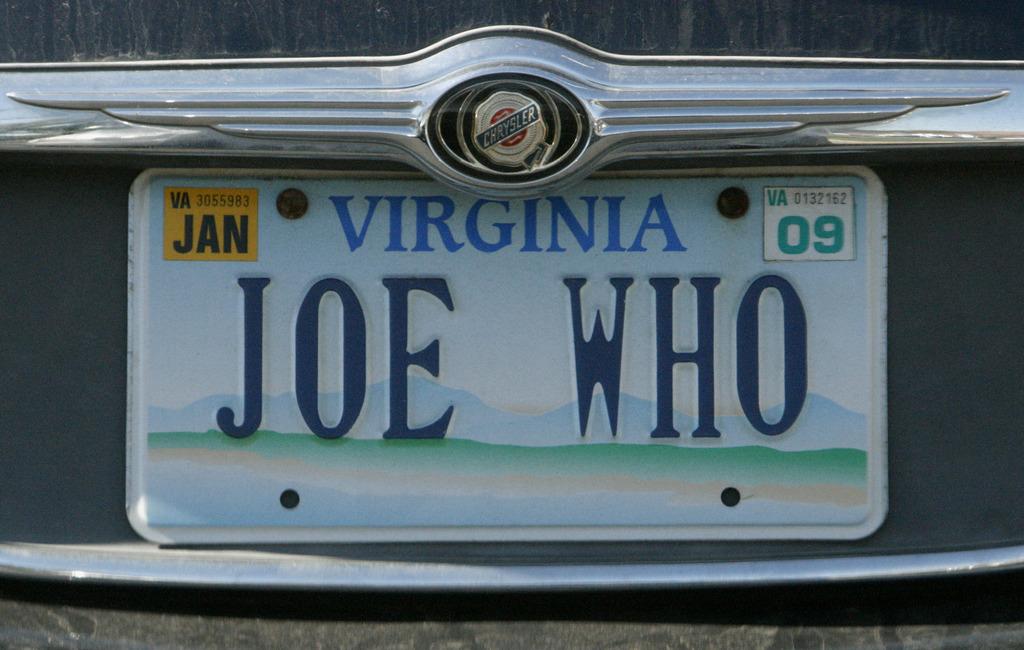What month does this license plate expire?
Your answer should be compact. Jan. 